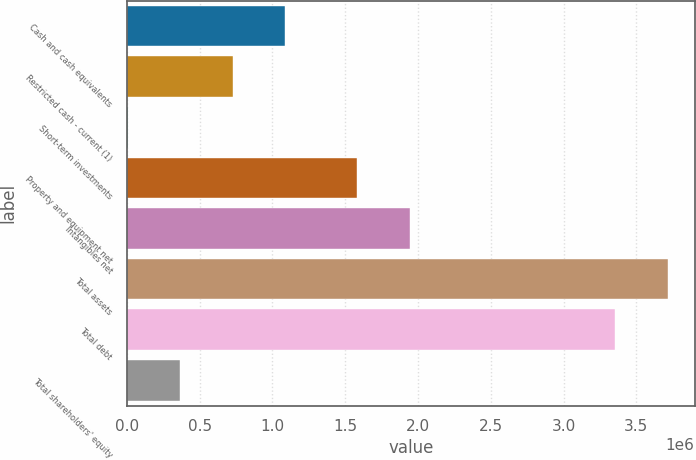Convert chart to OTSL. <chart><loc_0><loc_0><loc_500><loc_500><bar_chart><fcel>Cash and cash equivalents<fcel>Restricted cash - current (1)<fcel>Short-term investments<fcel>Property and equipment net<fcel>Intangibles net<fcel>Total assets<fcel>Total debt<fcel>Total shareholders' equity<nl><fcel>1.08596e+06<fcel>725898<fcel>5773<fcel>1.58339e+06<fcel>1.94346e+06<fcel>3.71455e+06<fcel>3.35448e+06<fcel>365836<nl></chart> 